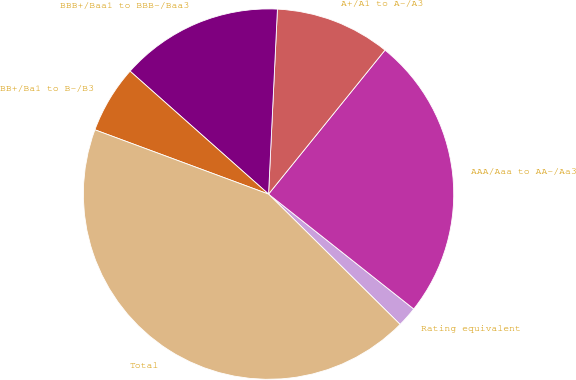Convert chart to OTSL. <chart><loc_0><loc_0><loc_500><loc_500><pie_chart><fcel>Rating equivalent<fcel>AAA/Aaa to AA-/Aa3<fcel>A+/A1 to A-/A3<fcel>BBB+/Baa1 to BBB-/Baa3<fcel>BB+/Ba1 to B-/B3<fcel>Total<nl><fcel>1.77%<fcel>24.83%<fcel>10.06%<fcel>14.21%<fcel>5.91%<fcel>43.22%<nl></chart> 